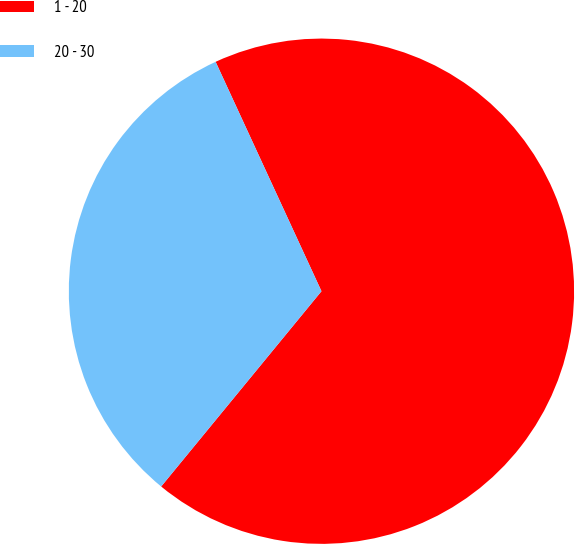Convert chart. <chart><loc_0><loc_0><loc_500><loc_500><pie_chart><fcel>1 - 20<fcel>20 - 30<nl><fcel>67.82%<fcel>32.18%<nl></chart> 